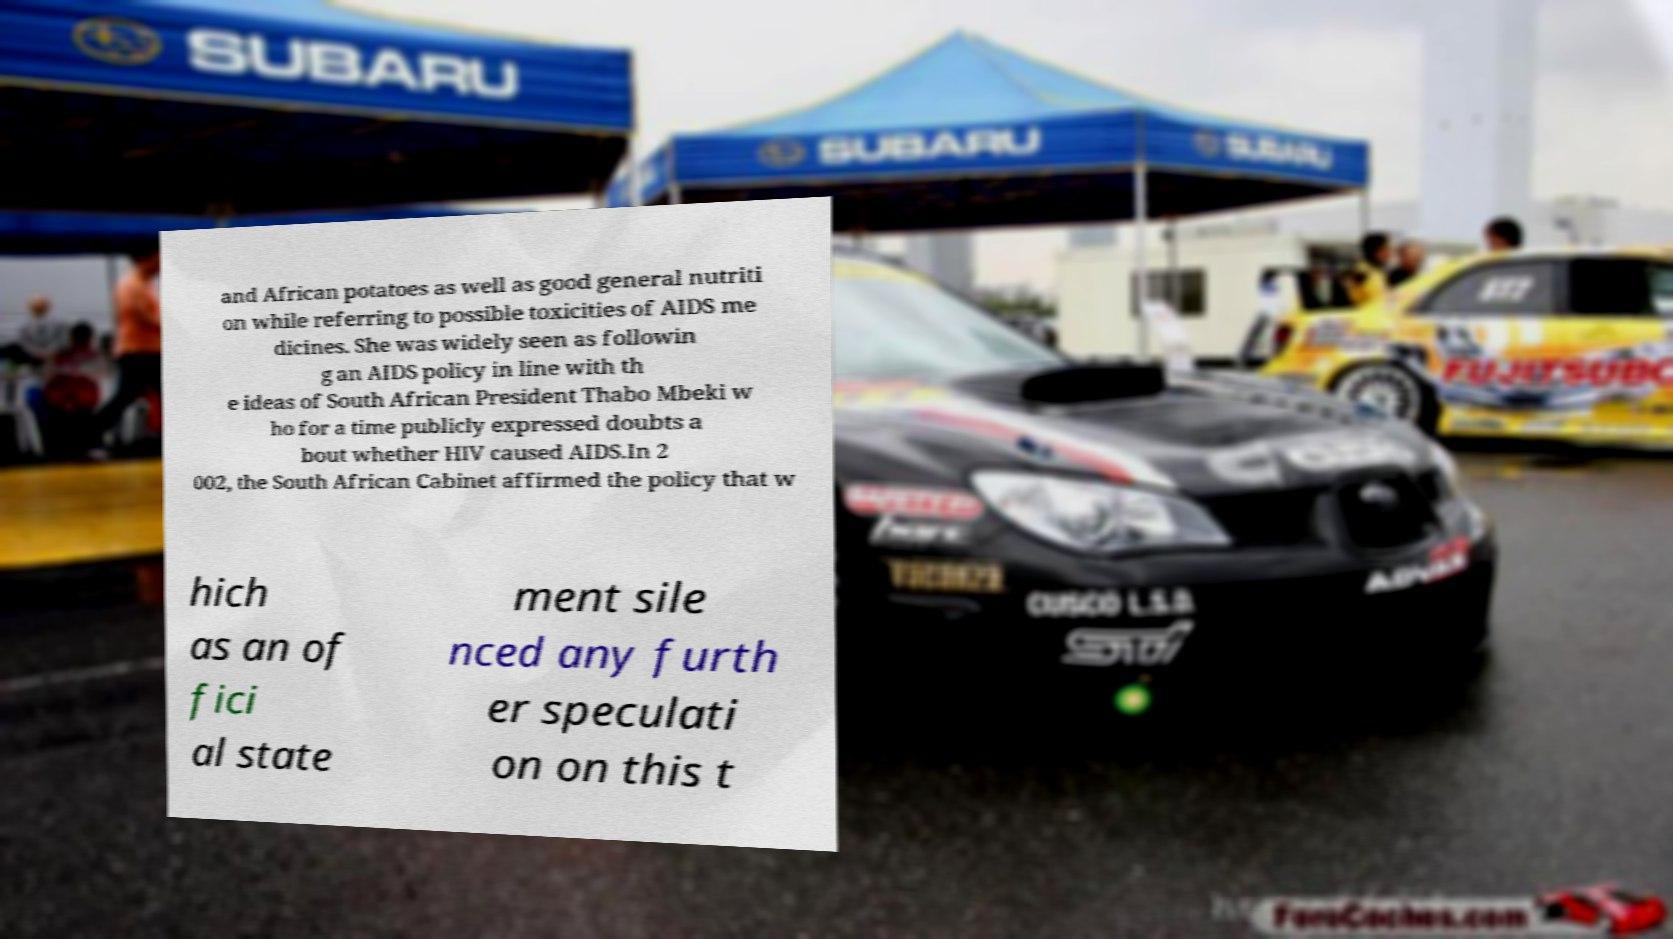Can you accurately transcribe the text from the provided image for me? and African potatoes as well as good general nutriti on while referring to possible toxicities of AIDS me dicines. She was widely seen as followin g an AIDS policy in line with th e ideas of South African President Thabo Mbeki w ho for a time publicly expressed doubts a bout whether HIV caused AIDS.In 2 002, the South African Cabinet affirmed the policy that w hich as an of fici al state ment sile nced any furth er speculati on on this t 